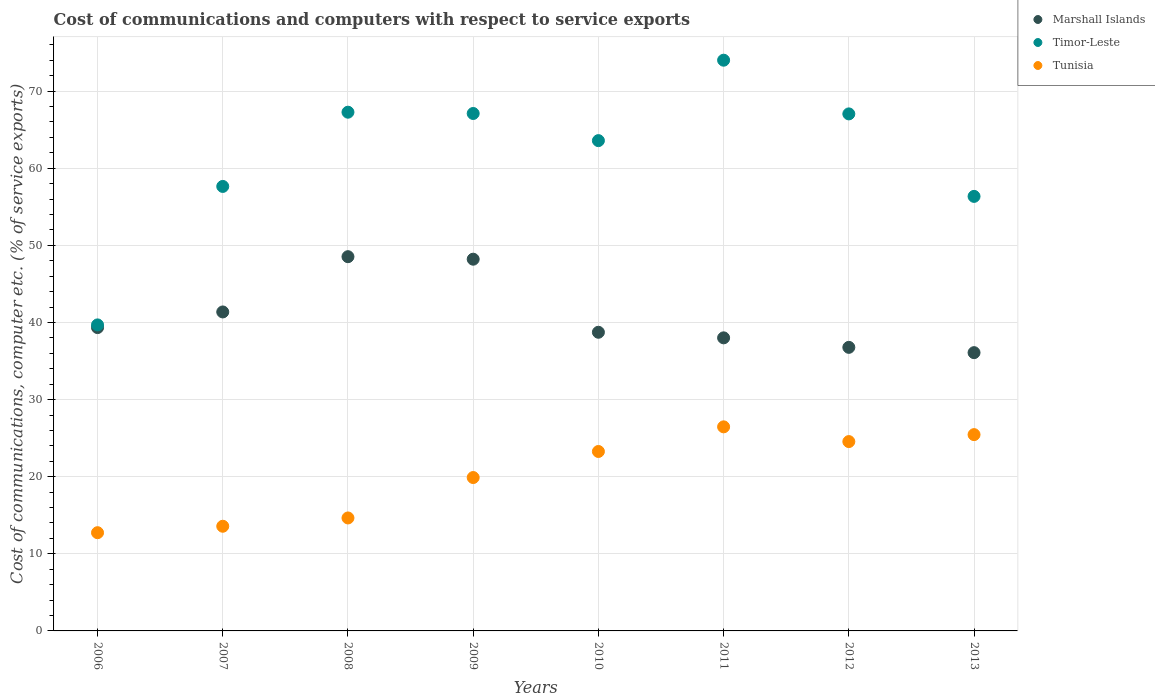Is the number of dotlines equal to the number of legend labels?
Make the answer very short. Yes. What is the cost of communications and computers in Timor-Leste in 2012?
Offer a very short reply. 67.05. Across all years, what is the maximum cost of communications and computers in Timor-Leste?
Keep it short and to the point. 74.01. Across all years, what is the minimum cost of communications and computers in Marshall Islands?
Your answer should be compact. 36.09. In which year was the cost of communications and computers in Timor-Leste minimum?
Keep it short and to the point. 2006. What is the total cost of communications and computers in Marshall Islands in the graph?
Your answer should be very brief. 327.03. What is the difference between the cost of communications and computers in Tunisia in 2009 and that in 2010?
Ensure brevity in your answer.  -3.38. What is the difference between the cost of communications and computers in Marshall Islands in 2013 and the cost of communications and computers in Timor-Leste in 2007?
Your response must be concise. -21.56. What is the average cost of communications and computers in Tunisia per year?
Provide a succinct answer. 20.07. In the year 2008, what is the difference between the cost of communications and computers in Tunisia and cost of communications and computers in Marshall Islands?
Your answer should be compact. -33.88. What is the ratio of the cost of communications and computers in Timor-Leste in 2010 to that in 2011?
Offer a terse response. 0.86. Is the difference between the cost of communications and computers in Tunisia in 2009 and 2012 greater than the difference between the cost of communications and computers in Marshall Islands in 2009 and 2012?
Your response must be concise. No. What is the difference between the highest and the second highest cost of communications and computers in Marshall Islands?
Make the answer very short. 0.33. What is the difference between the highest and the lowest cost of communications and computers in Marshall Islands?
Give a very brief answer. 12.45. In how many years, is the cost of communications and computers in Marshall Islands greater than the average cost of communications and computers in Marshall Islands taken over all years?
Give a very brief answer. 3. Is the sum of the cost of communications and computers in Tunisia in 2010 and 2011 greater than the maximum cost of communications and computers in Timor-Leste across all years?
Ensure brevity in your answer.  No. Is it the case that in every year, the sum of the cost of communications and computers in Timor-Leste and cost of communications and computers in Tunisia  is greater than the cost of communications and computers in Marshall Islands?
Give a very brief answer. Yes. How many dotlines are there?
Your response must be concise. 3. How many years are there in the graph?
Your response must be concise. 8. What is the difference between two consecutive major ticks on the Y-axis?
Make the answer very short. 10. Does the graph contain any zero values?
Offer a very short reply. No. Where does the legend appear in the graph?
Your answer should be compact. Top right. How are the legend labels stacked?
Make the answer very short. Vertical. What is the title of the graph?
Give a very brief answer. Cost of communications and computers with respect to service exports. Does "Tuvalu" appear as one of the legend labels in the graph?
Offer a very short reply. No. What is the label or title of the Y-axis?
Make the answer very short. Cost of communications, computer etc. (% of service exports). What is the Cost of communications, computer etc. (% of service exports) of Marshall Islands in 2006?
Give a very brief answer. 39.34. What is the Cost of communications, computer etc. (% of service exports) in Timor-Leste in 2006?
Provide a succinct answer. 39.69. What is the Cost of communications, computer etc. (% of service exports) in Tunisia in 2006?
Offer a terse response. 12.74. What is the Cost of communications, computer etc. (% of service exports) in Marshall Islands in 2007?
Your answer should be very brief. 41.36. What is the Cost of communications, computer etc. (% of service exports) of Timor-Leste in 2007?
Your answer should be compact. 57.64. What is the Cost of communications, computer etc. (% of service exports) of Tunisia in 2007?
Your answer should be compact. 13.57. What is the Cost of communications, computer etc. (% of service exports) in Marshall Islands in 2008?
Provide a succinct answer. 48.53. What is the Cost of communications, computer etc. (% of service exports) in Timor-Leste in 2008?
Ensure brevity in your answer.  67.27. What is the Cost of communications, computer etc. (% of service exports) in Tunisia in 2008?
Your answer should be very brief. 14.65. What is the Cost of communications, computer etc. (% of service exports) of Marshall Islands in 2009?
Offer a very short reply. 48.2. What is the Cost of communications, computer etc. (% of service exports) of Timor-Leste in 2009?
Offer a very short reply. 67.1. What is the Cost of communications, computer etc. (% of service exports) of Tunisia in 2009?
Offer a terse response. 19.89. What is the Cost of communications, computer etc. (% of service exports) of Marshall Islands in 2010?
Provide a short and direct response. 38.73. What is the Cost of communications, computer etc. (% of service exports) in Timor-Leste in 2010?
Provide a succinct answer. 63.58. What is the Cost of communications, computer etc. (% of service exports) in Tunisia in 2010?
Provide a short and direct response. 23.27. What is the Cost of communications, computer etc. (% of service exports) of Marshall Islands in 2011?
Make the answer very short. 38.01. What is the Cost of communications, computer etc. (% of service exports) in Timor-Leste in 2011?
Keep it short and to the point. 74.01. What is the Cost of communications, computer etc. (% of service exports) of Tunisia in 2011?
Provide a succinct answer. 26.46. What is the Cost of communications, computer etc. (% of service exports) in Marshall Islands in 2012?
Offer a terse response. 36.77. What is the Cost of communications, computer etc. (% of service exports) of Timor-Leste in 2012?
Your answer should be very brief. 67.05. What is the Cost of communications, computer etc. (% of service exports) of Tunisia in 2012?
Give a very brief answer. 24.55. What is the Cost of communications, computer etc. (% of service exports) in Marshall Islands in 2013?
Provide a succinct answer. 36.09. What is the Cost of communications, computer etc. (% of service exports) in Timor-Leste in 2013?
Provide a succinct answer. 56.35. What is the Cost of communications, computer etc. (% of service exports) of Tunisia in 2013?
Give a very brief answer. 25.46. Across all years, what is the maximum Cost of communications, computer etc. (% of service exports) in Marshall Islands?
Ensure brevity in your answer.  48.53. Across all years, what is the maximum Cost of communications, computer etc. (% of service exports) of Timor-Leste?
Ensure brevity in your answer.  74.01. Across all years, what is the maximum Cost of communications, computer etc. (% of service exports) in Tunisia?
Your answer should be very brief. 26.46. Across all years, what is the minimum Cost of communications, computer etc. (% of service exports) in Marshall Islands?
Your answer should be very brief. 36.09. Across all years, what is the minimum Cost of communications, computer etc. (% of service exports) in Timor-Leste?
Provide a succinct answer. 39.69. Across all years, what is the minimum Cost of communications, computer etc. (% of service exports) of Tunisia?
Offer a terse response. 12.74. What is the total Cost of communications, computer etc. (% of service exports) of Marshall Islands in the graph?
Provide a succinct answer. 327.03. What is the total Cost of communications, computer etc. (% of service exports) in Timor-Leste in the graph?
Offer a terse response. 492.68. What is the total Cost of communications, computer etc. (% of service exports) in Tunisia in the graph?
Provide a succinct answer. 160.59. What is the difference between the Cost of communications, computer etc. (% of service exports) of Marshall Islands in 2006 and that in 2007?
Provide a succinct answer. -2.03. What is the difference between the Cost of communications, computer etc. (% of service exports) in Timor-Leste in 2006 and that in 2007?
Give a very brief answer. -17.96. What is the difference between the Cost of communications, computer etc. (% of service exports) in Tunisia in 2006 and that in 2007?
Keep it short and to the point. -0.84. What is the difference between the Cost of communications, computer etc. (% of service exports) of Marshall Islands in 2006 and that in 2008?
Provide a short and direct response. -9.19. What is the difference between the Cost of communications, computer etc. (% of service exports) of Timor-Leste in 2006 and that in 2008?
Your answer should be compact. -27.58. What is the difference between the Cost of communications, computer etc. (% of service exports) of Tunisia in 2006 and that in 2008?
Provide a succinct answer. -1.91. What is the difference between the Cost of communications, computer etc. (% of service exports) in Marshall Islands in 2006 and that in 2009?
Ensure brevity in your answer.  -8.87. What is the difference between the Cost of communications, computer etc. (% of service exports) of Timor-Leste in 2006 and that in 2009?
Offer a very short reply. -27.41. What is the difference between the Cost of communications, computer etc. (% of service exports) of Tunisia in 2006 and that in 2009?
Ensure brevity in your answer.  -7.15. What is the difference between the Cost of communications, computer etc. (% of service exports) of Marshall Islands in 2006 and that in 2010?
Keep it short and to the point. 0.61. What is the difference between the Cost of communications, computer etc. (% of service exports) in Timor-Leste in 2006 and that in 2010?
Provide a succinct answer. -23.89. What is the difference between the Cost of communications, computer etc. (% of service exports) in Tunisia in 2006 and that in 2010?
Offer a very short reply. -10.53. What is the difference between the Cost of communications, computer etc. (% of service exports) in Marshall Islands in 2006 and that in 2011?
Offer a very short reply. 1.33. What is the difference between the Cost of communications, computer etc. (% of service exports) of Timor-Leste in 2006 and that in 2011?
Ensure brevity in your answer.  -34.33. What is the difference between the Cost of communications, computer etc. (% of service exports) of Tunisia in 2006 and that in 2011?
Provide a short and direct response. -13.73. What is the difference between the Cost of communications, computer etc. (% of service exports) in Marshall Islands in 2006 and that in 2012?
Make the answer very short. 2.56. What is the difference between the Cost of communications, computer etc. (% of service exports) of Timor-Leste in 2006 and that in 2012?
Provide a succinct answer. -27.36. What is the difference between the Cost of communications, computer etc. (% of service exports) of Tunisia in 2006 and that in 2012?
Make the answer very short. -11.82. What is the difference between the Cost of communications, computer etc. (% of service exports) in Marshall Islands in 2006 and that in 2013?
Give a very brief answer. 3.25. What is the difference between the Cost of communications, computer etc. (% of service exports) in Timor-Leste in 2006 and that in 2013?
Ensure brevity in your answer.  -16.66. What is the difference between the Cost of communications, computer etc. (% of service exports) in Tunisia in 2006 and that in 2013?
Provide a succinct answer. -12.72. What is the difference between the Cost of communications, computer etc. (% of service exports) in Marshall Islands in 2007 and that in 2008?
Provide a succinct answer. -7.17. What is the difference between the Cost of communications, computer etc. (% of service exports) in Timor-Leste in 2007 and that in 2008?
Provide a succinct answer. -9.63. What is the difference between the Cost of communications, computer etc. (% of service exports) in Tunisia in 2007 and that in 2008?
Offer a very short reply. -1.08. What is the difference between the Cost of communications, computer etc. (% of service exports) in Marshall Islands in 2007 and that in 2009?
Your answer should be very brief. -6.84. What is the difference between the Cost of communications, computer etc. (% of service exports) in Timor-Leste in 2007 and that in 2009?
Provide a succinct answer. -9.46. What is the difference between the Cost of communications, computer etc. (% of service exports) in Tunisia in 2007 and that in 2009?
Keep it short and to the point. -6.32. What is the difference between the Cost of communications, computer etc. (% of service exports) in Marshall Islands in 2007 and that in 2010?
Keep it short and to the point. 2.63. What is the difference between the Cost of communications, computer etc. (% of service exports) of Timor-Leste in 2007 and that in 2010?
Ensure brevity in your answer.  -5.94. What is the difference between the Cost of communications, computer etc. (% of service exports) of Tunisia in 2007 and that in 2010?
Your answer should be very brief. -9.7. What is the difference between the Cost of communications, computer etc. (% of service exports) of Marshall Islands in 2007 and that in 2011?
Offer a terse response. 3.36. What is the difference between the Cost of communications, computer etc. (% of service exports) of Timor-Leste in 2007 and that in 2011?
Ensure brevity in your answer.  -16.37. What is the difference between the Cost of communications, computer etc. (% of service exports) in Tunisia in 2007 and that in 2011?
Your response must be concise. -12.89. What is the difference between the Cost of communications, computer etc. (% of service exports) of Marshall Islands in 2007 and that in 2012?
Provide a succinct answer. 4.59. What is the difference between the Cost of communications, computer etc. (% of service exports) in Timor-Leste in 2007 and that in 2012?
Give a very brief answer. -9.41. What is the difference between the Cost of communications, computer etc. (% of service exports) in Tunisia in 2007 and that in 2012?
Give a very brief answer. -10.98. What is the difference between the Cost of communications, computer etc. (% of service exports) of Marshall Islands in 2007 and that in 2013?
Your response must be concise. 5.28. What is the difference between the Cost of communications, computer etc. (% of service exports) in Timor-Leste in 2007 and that in 2013?
Your response must be concise. 1.29. What is the difference between the Cost of communications, computer etc. (% of service exports) of Tunisia in 2007 and that in 2013?
Your answer should be compact. -11.88. What is the difference between the Cost of communications, computer etc. (% of service exports) in Marshall Islands in 2008 and that in 2009?
Provide a succinct answer. 0.33. What is the difference between the Cost of communications, computer etc. (% of service exports) in Timor-Leste in 2008 and that in 2009?
Keep it short and to the point. 0.17. What is the difference between the Cost of communications, computer etc. (% of service exports) in Tunisia in 2008 and that in 2009?
Offer a terse response. -5.24. What is the difference between the Cost of communications, computer etc. (% of service exports) of Marshall Islands in 2008 and that in 2010?
Your response must be concise. 9.8. What is the difference between the Cost of communications, computer etc. (% of service exports) in Timor-Leste in 2008 and that in 2010?
Offer a very short reply. 3.69. What is the difference between the Cost of communications, computer etc. (% of service exports) in Tunisia in 2008 and that in 2010?
Your answer should be very brief. -8.62. What is the difference between the Cost of communications, computer etc. (% of service exports) of Marshall Islands in 2008 and that in 2011?
Offer a terse response. 10.52. What is the difference between the Cost of communications, computer etc. (% of service exports) of Timor-Leste in 2008 and that in 2011?
Offer a very short reply. -6.74. What is the difference between the Cost of communications, computer etc. (% of service exports) of Tunisia in 2008 and that in 2011?
Your answer should be compact. -11.81. What is the difference between the Cost of communications, computer etc. (% of service exports) in Marshall Islands in 2008 and that in 2012?
Provide a short and direct response. 11.76. What is the difference between the Cost of communications, computer etc. (% of service exports) of Timor-Leste in 2008 and that in 2012?
Offer a terse response. 0.22. What is the difference between the Cost of communications, computer etc. (% of service exports) of Tunisia in 2008 and that in 2012?
Your response must be concise. -9.9. What is the difference between the Cost of communications, computer etc. (% of service exports) in Marshall Islands in 2008 and that in 2013?
Your answer should be compact. 12.45. What is the difference between the Cost of communications, computer etc. (% of service exports) of Timor-Leste in 2008 and that in 2013?
Give a very brief answer. 10.92. What is the difference between the Cost of communications, computer etc. (% of service exports) of Tunisia in 2008 and that in 2013?
Give a very brief answer. -10.81. What is the difference between the Cost of communications, computer etc. (% of service exports) of Marshall Islands in 2009 and that in 2010?
Ensure brevity in your answer.  9.48. What is the difference between the Cost of communications, computer etc. (% of service exports) in Timor-Leste in 2009 and that in 2010?
Keep it short and to the point. 3.52. What is the difference between the Cost of communications, computer etc. (% of service exports) in Tunisia in 2009 and that in 2010?
Ensure brevity in your answer.  -3.38. What is the difference between the Cost of communications, computer etc. (% of service exports) of Marshall Islands in 2009 and that in 2011?
Keep it short and to the point. 10.2. What is the difference between the Cost of communications, computer etc. (% of service exports) in Timor-Leste in 2009 and that in 2011?
Keep it short and to the point. -6.91. What is the difference between the Cost of communications, computer etc. (% of service exports) of Tunisia in 2009 and that in 2011?
Offer a terse response. -6.57. What is the difference between the Cost of communications, computer etc. (% of service exports) of Marshall Islands in 2009 and that in 2012?
Your answer should be compact. 11.43. What is the difference between the Cost of communications, computer etc. (% of service exports) of Timor-Leste in 2009 and that in 2012?
Offer a very short reply. 0.05. What is the difference between the Cost of communications, computer etc. (% of service exports) of Tunisia in 2009 and that in 2012?
Your answer should be compact. -4.66. What is the difference between the Cost of communications, computer etc. (% of service exports) in Marshall Islands in 2009 and that in 2013?
Provide a short and direct response. 12.12. What is the difference between the Cost of communications, computer etc. (% of service exports) in Timor-Leste in 2009 and that in 2013?
Your answer should be compact. 10.75. What is the difference between the Cost of communications, computer etc. (% of service exports) in Tunisia in 2009 and that in 2013?
Offer a terse response. -5.57. What is the difference between the Cost of communications, computer etc. (% of service exports) of Marshall Islands in 2010 and that in 2011?
Give a very brief answer. 0.72. What is the difference between the Cost of communications, computer etc. (% of service exports) of Timor-Leste in 2010 and that in 2011?
Provide a short and direct response. -10.43. What is the difference between the Cost of communications, computer etc. (% of service exports) in Tunisia in 2010 and that in 2011?
Provide a succinct answer. -3.2. What is the difference between the Cost of communications, computer etc. (% of service exports) of Marshall Islands in 2010 and that in 2012?
Provide a short and direct response. 1.96. What is the difference between the Cost of communications, computer etc. (% of service exports) of Timor-Leste in 2010 and that in 2012?
Give a very brief answer. -3.47. What is the difference between the Cost of communications, computer etc. (% of service exports) of Tunisia in 2010 and that in 2012?
Offer a terse response. -1.28. What is the difference between the Cost of communications, computer etc. (% of service exports) in Marshall Islands in 2010 and that in 2013?
Give a very brief answer. 2.64. What is the difference between the Cost of communications, computer etc. (% of service exports) in Timor-Leste in 2010 and that in 2013?
Your answer should be compact. 7.23. What is the difference between the Cost of communications, computer etc. (% of service exports) of Tunisia in 2010 and that in 2013?
Make the answer very short. -2.19. What is the difference between the Cost of communications, computer etc. (% of service exports) in Marshall Islands in 2011 and that in 2012?
Provide a short and direct response. 1.23. What is the difference between the Cost of communications, computer etc. (% of service exports) in Timor-Leste in 2011 and that in 2012?
Keep it short and to the point. 6.96. What is the difference between the Cost of communications, computer etc. (% of service exports) of Tunisia in 2011 and that in 2012?
Your response must be concise. 1.91. What is the difference between the Cost of communications, computer etc. (% of service exports) in Marshall Islands in 2011 and that in 2013?
Keep it short and to the point. 1.92. What is the difference between the Cost of communications, computer etc. (% of service exports) of Timor-Leste in 2011 and that in 2013?
Provide a short and direct response. 17.66. What is the difference between the Cost of communications, computer etc. (% of service exports) of Tunisia in 2011 and that in 2013?
Provide a succinct answer. 1.01. What is the difference between the Cost of communications, computer etc. (% of service exports) in Marshall Islands in 2012 and that in 2013?
Make the answer very short. 0.69. What is the difference between the Cost of communications, computer etc. (% of service exports) in Timor-Leste in 2012 and that in 2013?
Offer a very short reply. 10.7. What is the difference between the Cost of communications, computer etc. (% of service exports) of Tunisia in 2012 and that in 2013?
Your response must be concise. -0.9. What is the difference between the Cost of communications, computer etc. (% of service exports) in Marshall Islands in 2006 and the Cost of communications, computer etc. (% of service exports) in Timor-Leste in 2007?
Offer a terse response. -18.31. What is the difference between the Cost of communications, computer etc. (% of service exports) in Marshall Islands in 2006 and the Cost of communications, computer etc. (% of service exports) in Tunisia in 2007?
Offer a very short reply. 25.76. What is the difference between the Cost of communications, computer etc. (% of service exports) in Timor-Leste in 2006 and the Cost of communications, computer etc. (% of service exports) in Tunisia in 2007?
Offer a very short reply. 26.11. What is the difference between the Cost of communications, computer etc. (% of service exports) of Marshall Islands in 2006 and the Cost of communications, computer etc. (% of service exports) of Timor-Leste in 2008?
Give a very brief answer. -27.93. What is the difference between the Cost of communications, computer etc. (% of service exports) in Marshall Islands in 2006 and the Cost of communications, computer etc. (% of service exports) in Tunisia in 2008?
Ensure brevity in your answer.  24.69. What is the difference between the Cost of communications, computer etc. (% of service exports) in Timor-Leste in 2006 and the Cost of communications, computer etc. (% of service exports) in Tunisia in 2008?
Your answer should be compact. 25.04. What is the difference between the Cost of communications, computer etc. (% of service exports) in Marshall Islands in 2006 and the Cost of communications, computer etc. (% of service exports) in Timor-Leste in 2009?
Offer a very short reply. -27.76. What is the difference between the Cost of communications, computer etc. (% of service exports) of Marshall Islands in 2006 and the Cost of communications, computer etc. (% of service exports) of Tunisia in 2009?
Offer a very short reply. 19.45. What is the difference between the Cost of communications, computer etc. (% of service exports) in Timor-Leste in 2006 and the Cost of communications, computer etc. (% of service exports) in Tunisia in 2009?
Your answer should be compact. 19.8. What is the difference between the Cost of communications, computer etc. (% of service exports) of Marshall Islands in 2006 and the Cost of communications, computer etc. (% of service exports) of Timor-Leste in 2010?
Provide a short and direct response. -24.24. What is the difference between the Cost of communications, computer etc. (% of service exports) in Marshall Islands in 2006 and the Cost of communications, computer etc. (% of service exports) in Tunisia in 2010?
Ensure brevity in your answer.  16.07. What is the difference between the Cost of communications, computer etc. (% of service exports) in Timor-Leste in 2006 and the Cost of communications, computer etc. (% of service exports) in Tunisia in 2010?
Give a very brief answer. 16.42. What is the difference between the Cost of communications, computer etc. (% of service exports) in Marshall Islands in 2006 and the Cost of communications, computer etc. (% of service exports) in Timor-Leste in 2011?
Provide a succinct answer. -34.67. What is the difference between the Cost of communications, computer etc. (% of service exports) in Marshall Islands in 2006 and the Cost of communications, computer etc. (% of service exports) in Tunisia in 2011?
Offer a terse response. 12.87. What is the difference between the Cost of communications, computer etc. (% of service exports) in Timor-Leste in 2006 and the Cost of communications, computer etc. (% of service exports) in Tunisia in 2011?
Keep it short and to the point. 13.22. What is the difference between the Cost of communications, computer etc. (% of service exports) in Marshall Islands in 2006 and the Cost of communications, computer etc. (% of service exports) in Timor-Leste in 2012?
Provide a short and direct response. -27.71. What is the difference between the Cost of communications, computer etc. (% of service exports) of Marshall Islands in 2006 and the Cost of communications, computer etc. (% of service exports) of Tunisia in 2012?
Make the answer very short. 14.78. What is the difference between the Cost of communications, computer etc. (% of service exports) in Timor-Leste in 2006 and the Cost of communications, computer etc. (% of service exports) in Tunisia in 2012?
Your answer should be compact. 15.13. What is the difference between the Cost of communications, computer etc. (% of service exports) of Marshall Islands in 2006 and the Cost of communications, computer etc. (% of service exports) of Timor-Leste in 2013?
Make the answer very short. -17.01. What is the difference between the Cost of communications, computer etc. (% of service exports) in Marshall Islands in 2006 and the Cost of communications, computer etc. (% of service exports) in Tunisia in 2013?
Make the answer very short. 13.88. What is the difference between the Cost of communications, computer etc. (% of service exports) in Timor-Leste in 2006 and the Cost of communications, computer etc. (% of service exports) in Tunisia in 2013?
Keep it short and to the point. 14.23. What is the difference between the Cost of communications, computer etc. (% of service exports) of Marshall Islands in 2007 and the Cost of communications, computer etc. (% of service exports) of Timor-Leste in 2008?
Ensure brevity in your answer.  -25.9. What is the difference between the Cost of communications, computer etc. (% of service exports) of Marshall Islands in 2007 and the Cost of communications, computer etc. (% of service exports) of Tunisia in 2008?
Ensure brevity in your answer.  26.71. What is the difference between the Cost of communications, computer etc. (% of service exports) of Timor-Leste in 2007 and the Cost of communications, computer etc. (% of service exports) of Tunisia in 2008?
Your answer should be very brief. 42.99. What is the difference between the Cost of communications, computer etc. (% of service exports) of Marshall Islands in 2007 and the Cost of communications, computer etc. (% of service exports) of Timor-Leste in 2009?
Offer a very short reply. -25.74. What is the difference between the Cost of communications, computer etc. (% of service exports) of Marshall Islands in 2007 and the Cost of communications, computer etc. (% of service exports) of Tunisia in 2009?
Ensure brevity in your answer.  21.47. What is the difference between the Cost of communications, computer etc. (% of service exports) of Timor-Leste in 2007 and the Cost of communications, computer etc. (% of service exports) of Tunisia in 2009?
Provide a succinct answer. 37.75. What is the difference between the Cost of communications, computer etc. (% of service exports) in Marshall Islands in 2007 and the Cost of communications, computer etc. (% of service exports) in Timor-Leste in 2010?
Your response must be concise. -22.22. What is the difference between the Cost of communications, computer etc. (% of service exports) in Marshall Islands in 2007 and the Cost of communications, computer etc. (% of service exports) in Tunisia in 2010?
Offer a terse response. 18.09. What is the difference between the Cost of communications, computer etc. (% of service exports) of Timor-Leste in 2007 and the Cost of communications, computer etc. (% of service exports) of Tunisia in 2010?
Give a very brief answer. 34.37. What is the difference between the Cost of communications, computer etc. (% of service exports) in Marshall Islands in 2007 and the Cost of communications, computer etc. (% of service exports) in Timor-Leste in 2011?
Your response must be concise. -32.65. What is the difference between the Cost of communications, computer etc. (% of service exports) in Marshall Islands in 2007 and the Cost of communications, computer etc. (% of service exports) in Tunisia in 2011?
Keep it short and to the point. 14.9. What is the difference between the Cost of communications, computer etc. (% of service exports) of Timor-Leste in 2007 and the Cost of communications, computer etc. (% of service exports) of Tunisia in 2011?
Offer a terse response. 31.18. What is the difference between the Cost of communications, computer etc. (% of service exports) in Marshall Islands in 2007 and the Cost of communications, computer etc. (% of service exports) in Timor-Leste in 2012?
Your answer should be very brief. -25.68. What is the difference between the Cost of communications, computer etc. (% of service exports) in Marshall Islands in 2007 and the Cost of communications, computer etc. (% of service exports) in Tunisia in 2012?
Ensure brevity in your answer.  16.81. What is the difference between the Cost of communications, computer etc. (% of service exports) of Timor-Leste in 2007 and the Cost of communications, computer etc. (% of service exports) of Tunisia in 2012?
Your answer should be very brief. 33.09. What is the difference between the Cost of communications, computer etc. (% of service exports) in Marshall Islands in 2007 and the Cost of communications, computer etc. (% of service exports) in Timor-Leste in 2013?
Give a very brief answer. -14.99. What is the difference between the Cost of communications, computer etc. (% of service exports) in Marshall Islands in 2007 and the Cost of communications, computer etc. (% of service exports) in Tunisia in 2013?
Offer a terse response. 15.91. What is the difference between the Cost of communications, computer etc. (% of service exports) of Timor-Leste in 2007 and the Cost of communications, computer etc. (% of service exports) of Tunisia in 2013?
Offer a very short reply. 32.19. What is the difference between the Cost of communications, computer etc. (% of service exports) in Marshall Islands in 2008 and the Cost of communications, computer etc. (% of service exports) in Timor-Leste in 2009?
Your response must be concise. -18.57. What is the difference between the Cost of communications, computer etc. (% of service exports) in Marshall Islands in 2008 and the Cost of communications, computer etc. (% of service exports) in Tunisia in 2009?
Your answer should be compact. 28.64. What is the difference between the Cost of communications, computer etc. (% of service exports) in Timor-Leste in 2008 and the Cost of communications, computer etc. (% of service exports) in Tunisia in 2009?
Your answer should be compact. 47.38. What is the difference between the Cost of communications, computer etc. (% of service exports) in Marshall Islands in 2008 and the Cost of communications, computer etc. (% of service exports) in Timor-Leste in 2010?
Provide a short and direct response. -15.05. What is the difference between the Cost of communications, computer etc. (% of service exports) of Marshall Islands in 2008 and the Cost of communications, computer etc. (% of service exports) of Tunisia in 2010?
Make the answer very short. 25.26. What is the difference between the Cost of communications, computer etc. (% of service exports) of Timor-Leste in 2008 and the Cost of communications, computer etc. (% of service exports) of Tunisia in 2010?
Your answer should be very brief. 44. What is the difference between the Cost of communications, computer etc. (% of service exports) of Marshall Islands in 2008 and the Cost of communications, computer etc. (% of service exports) of Timor-Leste in 2011?
Offer a very short reply. -25.48. What is the difference between the Cost of communications, computer etc. (% of service exports) in Marshall Islands in 2008 and the Cost of communications, computer etc. (% of service exports) in Tunisia in 2011?
Your answer should be compact. 22.07. What is the difference between the Cost of communications, computer etc. (% of service exports) in Timor-Leste in 2008 and the Cost of communications, computer etc. (% of service exports) in Tunisia in 2011?
Keep it short and to the point. 40.8. What is the difference between the Cost of communications, computer etc. (% of service exports) in Marshall Islands in 2008 and the Cost of communications, computer etc. (% of service exports) in Timor-Leste in 2012?
Make the answer very short. -18.52. What is the difference between the Cost of communications, computer etc. (% of service exports) in Marshall Islands in 2008 and the Cost of communications, computer etc. (% of service exports) in Tunisia in 2012?
Make the answer very short. 23.98. What is the difference between the Cost of communications, computer etc. (% of service exports) of Timor-Leste in 2008 and the Cost of communications, computer etc. (% of service exports) of Tunisia in 2012?
Provide a short and direct response. 42.71. What is the difference between the Cost of communications, computer etc. (% of service exports) in Marshall Islands in 2008 and the Cost of communications, computer etc. (% of service exports) in Timor-Leste in 2013?
Provide a succinct answer. -7.82. What is the difference between the Cost of communications, computer etc. (% of service exports) in Marshall Islands in 2008 and the Cost of communications, computer etc. (% of service exports) in Tunisia in 2013?
Your response must be concise. 23.07. What is the difference between the Cost of communications, computer etc. (% of service exports) of Timor-Leste in 2008 and the Cost of communications, computer etc. (% of service exports) of Tunisia in 2013?
Give a very brief answer. 41.81. What is the difference between the Cost of communications, computer etc. (% of service exports) of Marshall Islands in 2009 and the Cost of communications, computer etc. (% of service exports) of Timor-Leste in 2010?
Ensure brevity in your answer.  -15.38. What is the difference between the Cost of communications, computer etc. (% of service exports) of Marshall Islands in 2009 and the Cost of communications, computer etc. (% of service exports) of Tunisia in 2010?
Offer a terse response. 24.94. What is the difference between the Cost of communications, computer etc. (% of service exports) of Timor-Leste in 2009 and the Cost of communications, computer etc. (% of service exports) of Tunisia in 2010?
Offer a very short reply. 43.83. What is the difference between the Cost of communications, computer etc. (% of service exports) in Marshall Islands in 2009 and the Cost of communications, computer etc. (% of service exports) in Timor-Leste in 2011?
Offer a terse response. -25.81. What is the difference between the Cost of communications, computer etc. (% of service exports) in Marshall Islands in 2009 and the Cost of communications, computer etc. (% of service exports) in Tunisia in 2011?
Provide a succinct answer. 21.74. What is the difference between the Cost of communications, computer etc. (% of service exports) of Timor-Leste in 2009 and the Cost of communications, computer etc. (% of service exports) of Tunisia in 2011?
Your answer should be compact. 40.64. What is the difference between the Cost of communications, computer etc. (% of service exports) of Marshall Islands in 2009 and the Cost of communications, computer etc. (% of service exports) of Timor-Leste in 2012?
Your answer should be compact. -18.84. What is the difference between the Cost of communications, computer etc. (% of service exports) in Marshall Islands in 2009 and the Cost of communications, computer etc. (% of service exports) in Tunisia in 2012?
Keep it short and to the point. 23.65. What is the difference between the Cost of communications, computer etc. (% of service exports) in Timor-Leste in 2009 and the Cost of communications, computer etc. (% of service exports) in Tunisia in 2012?
Provide a short and direct response. 42.55. What is the difference between the Cost of communications, computer etc. (% of service exports) in Marshall Islands in 2009 and the Cost of communications, computer etc. (% of service exports) in Timor-Leste in 2013?
Your answer should be compact. -8.15. What is the difference between the Cost of communications, computer etc. (% of service exports) of Marshall Islands in 2009 and the Cost of communications, computer etc. (% of service exports) of Tunisia in 2013?
Your response must be concise. 22.75. What is the difference between the Cost of communications, computer etc. (% of service exports) in Timor-Leste in 2009 and the Cost of communications, computer etc. (% of service exports) in Tunisia in 2013?
Offer a very short reply. 41.64. What is the difference between the Cost of communications, computer etc. (% of service exports) of Marshall Islands in 2010 and the Cost of communications, computer etc. (% of service exports) of Timor-Leste in 2011?
Your response must be concise. -35.28. What is the difference between the Cost of communications, computer etc. (% of service exports) of Marshall Islands in 2010 and the Cost of communications, computer etc. (% of service exports) of Tunisia in 2011?
Keep it short and to the point. 12.26. What is the difference between the Cost of communications, computer etc. (% of service exports) in Timor-Leste in 2010 and the Cost of communications, computer etc. (% of service exports) in Tunisia in 2011?
Ensure brevity in your answer.  37.12. What is the difference between the Cost of communications, computer etc. (% of service exports) in Marshall Islands in 2010 and the Cost of communications, computer etc. (% of service exports) in Timor-Leste in 2012?
Make the answer very short. -28.32. What is the difference between the Cost of communications, computer etc. (% of service exports) of Marshall Islands in 2010 and the Cost of communications, computer etc. (% of service exports) of Tunisia in 2012?
Offer a very short reply. 14.18. What is the difference between the Cost of communications, computer etc. (% of service exports) in Timor-Leste in 2010 and the Cost of communications, computer etc. (% of service exports) in Tunisia in 2012?
Your answer should be compact. 39.03. What is the difference between the Cost of communications, computer etc. (% of service exports) in Marshall Islands in 2010 and the Cost of communications, computer etc. (% of service exports) in Timor-Leste in 2013?
Make the answer very short. -17.62. What is the difference between the Cost of communications, computer etc. (% of service exports) in Marshall Islands in 2010 and the Cost of communications, computer etc. (% of service exports) in Tunisia in 2013?
Provide a short and direct response. 13.27. What is the difference between the Cost of communications, computer etc. (% of service exports) of Timor-Leste in 2010 and the Cost of communications, computer etc. (% of service exports) of Tunisia in 2013?
Offer a terse response. 38.12. What is the difference between the Cost of communications, computer etc. (% of service exports) in Marshall Islands in 2011 and the Cost of communications, computer etc. (% of service exports) in Timor-Leste in 2012?
Your response must be concise. -29.04. What is the difference between the Cost of communications, computer etc. (% of service exports) of Marshall Islands in 2011 and the Cost of communications, computer etc. (% of service exports) of Tunisia in 2012?
Your answer should be compact. 13.45. What is the difference between the Cost of communications, computer etc. (% of service exports) of Timor-Leste in 2011 and the Cost of communications, computer etc. (% of service exports) of Tunisia in 2012?
Ensure brevity in your answer.  49.46. What is the difference between the Cost of communications, computer etc. (% of service exports) in Marshall Islands in 2011 and the Cost of communications, computer etc. (% of service exports) in Timor-Leste in 2013?
Your answer should be compact. -18.34. What is the difference between the Cost of communications, computer etc. (% of service exports) of Marshall Islands in 2011 and the Cost of communications, computer etc. (% of service exports) of Tunisia in 2013?
Offer a terse response. 12.55. What is the difference between the Cost of communications, computer etc. (% of service exports) of Timor-Leste in 2011 and the Cost of communications, computer etc. (% of service exports) of Tunisia in 2013?
Ensure brevity in your answer.  48.55. What is the difference between the Cost of communications, computer etc. (% of service exports) in Marshall Islands in 2012 and the Cost of communications, computer etc. (% of service exports) in Timor-Leste in 2013?
Your answer should be compact. -19.58. What is the difference between the Cost of communications, computer etc. (% of service exports) in Marshall Islands in 2012 and the Cost of communications, computer etc. (% of service exports) in Tunisia in 2013?
Make the answer very short. 11.32. What is the difference between the Cost of communications, computer etc. (% of service exports) in Timor-Leste in 2012 and the Cost of communications, computer etc. (% of service exports) in Tunisia in 2013?
Your answer should be compact. 41.59. What is the average Cost of communications, computer etc. (% of service exports) in Marshall Islands per year?
Provide a short and direct response. 40.88. What is the average Cost of communications, computer etc. (% of service exports) of Timor-Leste per year?
Keep it short and to the point. 61.59. What is the average Cost of communications, computer etc. (% of service exports) of Tunisia per year?
Your response must be concise. 20.07. In the year 2006, what is the difference between the Cost of communications, computer etc. (% of service exports) in Marshall Islands and Cost of communications, computer etc. (% of service exports) in Timor-Leste?
Make the answer very short. -0.35. In the year 2006, what is the difference between the Cost of communications, computer etc. (% of service exports) of Marshall Islands and Cost of communications, computer etc. (% of service exports) of Tunisia?
Keep it short and to the point. 26.6. In the year 2006, what is the difference between the Cost of communications, computer etc. (% of service exports) in Timor-Leste and Cost of communications, computer etc. (% of service exports) in Tunisia?
Your answer should be compact. 26.95. In the year 2007, what is the difference between the Cost of communications, computer etc. (% of service exports) of Marshall Islands and Cost of communications, computer etc. (% of service exports) of Timor-Leste?
Provide a succinct answer. -16.28. In the year 2007, what is the difference between the Cost of communications, computer etc. (% of service exports) of Marshall Islands and Cost of communications, computer etc. (% of service exports) of Tunisia?
Provide a short and direct response. 27.79. In the year 2007, what is the difference between the Cost of communications, computer etc. (% of service exports) in Timor-Leste and Cost of communications, computer etc. (% of service exports) in Tunisia?
Your response must be concise. 44.07. In the year 2008, what is the difference between the Cost of communications, computer etc. (% of service exports) in Marshall Islands and Cost of communications, computer etc. (% of service exports) in Timor-Leste?
Your answer should be very brief. -18.74. In the year 2008, what is the difference between the Cost of communications, computer etc. (% of service exports) in Marshall Islands and Cost of communications, computer etc. (% of service exports) in Tunisia?
Ensure brevity in your answer.  33.88. In the year 2008, what is the difference between the Cost of communications, computer etc. (% of service exports) in Timor-Leste and Cost of communications, computer etc. (% of service exports) in Tunisia?
Your answer should be very brief. 52.62. In the year 2009, what is the difference between the Cost of communications, computer etc. (% of service exports) of Marshall Islands and Cost of communications, computer etc. (% of service exports) of Timor-Leste?
Keep it short and to the point. -18.9. In the year 2009, what is the difference between the Cost of communications, computer etc. (% of service exports) of Marshall Islands and Cost of communications, computer etc. (% of service exports) of Tunisia?
Give a very brief answer. 28.31. In the year 2009, what is the difference between the Cost of communications, computer etc. (% of service exports) of Timor-Leste and Cost of communications, computer etc. (% of service exports) of Tunisia?
Provide a short and direct response. 47.21. In the year 2010, what is the difference between the Cost of communications, computer etc. (% of service exports) in Marshall Islands and Cost of communications, computer etc. (% of service exports) in Timor-Leste?
Keep it short and to the point. -24.85. In the year 2010, what is the difference between the Cost of communications, computer etc. (% of service exports) in Marshall Islands and Cost of communications, computer etc. (% of service exports) in Tunisia?
Your answer should be compact. 15.46. In the year 2010, what is the difference between the Cost of communications, computer etc. (% of service exports) in Timor-Leste and Cost of communications, computer etc. (% of service exports) in Tunisia?
Provide a succinct answer. 40.31. In the year 2011, what is the difference between the Cost of communications, computer etc. (% of service exports) of Marshall Islands and Cost of communications, computer etc. (% of service exports) of Timor-Leste?
Ensure brevity in your answer.  -36. In the year 2011, what is the difference between the Cost of communications, computer etc. (% of service exports) in Marshall Islands and Cost of communications, computer etc. (% of service exports) in Tunisia?
Offer a terse response. 11.54. In the year 2011, what is the difference between the Cost of communications, computer etc. (% of service exports) in Timor-Leste and Cost of communications, computer etc. (% of service exports) in Tunisia?
Your response must be concise. 47.55. In the year 2012, what is the difference between the Cost of communications, computer etc. (% of service exports) of Marshall Islands and Cost of communications, computer etc. (% of service exports) of Timor-Leste?
Provide a succinct answer. -30.27. In the year 2012, what is the difference between the Cost of communications, computer etc. (% of service exports) in Marshall Islands and Cost of communications, computer etc. (% of service exports) in Tunisia?
Keep it short and to the point. 12.22. In the year 2012, what is the difference between the Cost of communications, computer etc. (% of service exports) in Timor-Leste and Cost of communications, computer etc. (% of service exports) in Tunisia?
Provide a short and direct response. 42.49. In the year 2013, what is the difference between the Cost of communications, computer etc. (% of service exports) of Marshall Islands and Cost of communications, computer etc. (% of service exports) of Timor-Leste?
Offer a very short reply. -20.26. In the year 2013, what is the difference between the Cost of communications, computer etc. (% of service exports) of Marshall Islands and Cost of communications, computer etc. (% of service exports) of Tunisia?
Provide a succinct answer. 10.63. In the year 2013, what is the difference between the Cost of communications, computer etc. (% of service exports) in Timor-Leste and Cost of communications, computer etc. (% of service exports) in Tunisia?
Make the answer very short. 30.89. What is the ratio of the Cost of communications, computer etc. (% of service exports) in Marshall Islands in 2006 to that in 2007?
Your response must be concise. 0.95. What is the ratio of the Cost of communications, computer etc. (% of service exports) of Timor-Leste in 2006 to that in 2007?
Ensure brevity in your answer.  0.69. What is the ratio of the Cost of communications, computer etc. (% of service exports) in Tunisia in 2006 to that in 2007?
Keep it short and to the point. 0.94. What is the ratio of the Cost of communications, computer etc. (% of service exports) in Marshall Islands in 2006 to that in 2008?
Offer a terse response. 0.81. What is the ratio of the Cost of communications, computer etc. (% of service exports) of Timor-Leste in 2006 to that in 2008?
Your response must be concise. 0.59. What is the ratio of the Cost of communications, computer etc. (% of service exports) of Tunisia in 2006 to that in 2008?
Provide a succinct answer. 0.87. What is the ratio of the Cost of communications, computer etc. (% of service exports) of Marshall Islands in 2006 to that in 2009?
Your answer should be very brief. 0.82. What is the ratio of the Cost of communications, computer etc. (% of service exports) in Timor-Leste in 2006 to that in 2009?
Ensure brevity in your answer.  0.59. What is the ratio of the Cost of communications, computer etc. (% of service exports) in Tunisia in 2006 to that in 2009?
Make the answer very short. 0.64. What is the ratio of the Cost of communications, computer etc. (% of service exports) in Marshall Islands in 2006 to that in 2010?
Your answer should be very brief. 1.02. What is the ratio of the Cost of communications, computer etc. (% of service exports) of Timor-Leste in 2006 to that in 2010?
Make the answer very short. 0.62. What is the ratio of the Cost of communications, computer etc. (% of service exports) in Tunisia in 2006 to that in 2010?
Offer a terse response. 0.55. What is the ratio of the Cost of communications, computer etc. (% of service exports) of Marshall Islands in 2006 to that in 2011?
Keep it short and to the point. 1.03. What is the ratio of the Cost of communications, computer etc. (% of service exports) in Timor-Leste in 2006 to that in 2011?
Give a very brief answer. 0.54. What is the ratio of the Cost of communications, computer etc. (% of service exports) in Tunisia in 2006 to that in 2011?
Provide a short and direct response. 0.48. What is the ratio of the Cost of communications, computer etc. (% of service exports) of Marshall Islands in 2006 to that in 2012?
Your answer should be compact. 1.07. What is the ratio of the Cost of communications, computer etc. (% of service exports) in Timor-Leste in 2006 to that in 2012?
Ensure brevity in your answer.  0.59. What is the ratio of the Cost of communications, computer etc. (% of service exports) in Tunisia in 2006 to that in 2012?
Ensure brevity in your answer.  0.52. What is the ratio of the Cost of communications, computer etc. (% of service exports) in Marshall Islands in 2006 to that in 2013?
Make the answer very short. 1.09. What is the ratio of the Cost of communications, computer etc. (% of service exports) of Timor-Leste in 2006 to that in 2013?
Offer a very short reply. 0.7. What is the ratio of the Cost of communications, computer etc. (% of service exports) in Tunisia in 2006 to that in 2013?
Provide a succinct answer. 0.5. What is the ratio of the Cost of communications, computer etc. (% of service exports) in Marshall Islands in 2007 to that in 2008?
Provide a succinct answer. 0.85. What is the ratio of the Cost of communications, computer etc. (% of service exports) of Timor-Leste in 2007 to that in 2008?
Provide a short and direct response. 0.86. What is the ratio of the Cost of communications, computer etc. (% of service exports) of Tunisia in 2007 to that in 2008?
Your answer should be compact. 0.93. What is the ratio of the Cost of communications, computer etc. (% of service exports) of Marshall Islands in 2007 to that in 2009?
Your answer should be very brief. 0.86. What is the ratio of the Cost of communications, computer etc. (% of service exports) in Timor-Leste in 2007 to that in 2009?
Give a very brief answer. 0.86. What is the ratio of the Cost of communications, computer etc. (% of service exports) in Tunisia in 2007 to that in 2009?
Ensure brevity in your answer.  0.68. What is the ratio of the Cost of communications, computer etc. (% of service exports) in Marshall Islands in 2007 to that in 2010?
Make the answer very short. 1.07. What is the ratio of the Cost of communications, computer etc. (% of service exports) in Timor-Leste in 2007 to that in 2010?
Make the answer very short. 0.91. What is the ratio of the Cost of communications, computer etc. (% of service exports) of Tunisia in 2007 to that in 2010?
Ensure brevity in your answer.  0.58. What is the ratio of the Cost of communications, computer etc. (% of service exports) of Marshall Islands in 2007 to that in 2011?
Give a very brief answer. 1.09. What is the ratio of the Cost of communications, computer etc. (% of service exports) of Timor-Leste in 2007 to that in 2011?
Keep it short and to the point. 0.78. What is the ratio of the Cost of communications, computer etc. (% of service exports) of Tunisia in 2007 to that in 2011?
Provide a short and direct response. 0.51. What is the ratio of the Cost of communications, computer etc. (% of service exports) of Marshall Islands in 2007 to that in 2012?
Offer a terse response. 1.12. What is the ratio of the Cost of communications, computer etc. (% of service exports) in Timor-Leste in 2007 to that in 2012?
Ensure brevity in your answer.  0.86. What is the ratio of the Cost of communications, computer etc. (% of service exports) in Tunisia in 2007 to that in 2012?
Your answer should be compact. 0.55. What is the ratio of the Cost of communications, computer etc. (% of service exports) in Marshall Islands in 2007 to that in 2013?
Your answer should be very brief. 1.15. What is the ratio of the Cost of communications, computer etc. (% of service exports) of Timor-Leste in 2007 to that in 2013?
Offer a terse response. 1.02. What is the ratio of the Cost of communications, computer etc. (% of service exports) of Tunisia in 2007 to that in 2013?
Make the answer very short. 0.53. What is the ratio of the Cost of communications, computer etc. (% of service exports) of Marshall Islands in 2008 to that in 2009?
Ensure brevity in your answer.  1.01. What is the ratio of the Cost of communications, computer etc. (% of service exports) in Timor-Leste in 2008 to that in 2009?
Provide a succinct answer. 1. What is the ratio of the Cost of communications, computer etc. (% of service exports) of Tunisia in 2008 to that in 2009?
Your answer should be very brief. 0.74. What is the ratio of the Cost of communications, computer etc. (% of service exports) of Marshall Islands in 2008 to that in 2010?
Ensure brevity in your answer.  1.25. What is the ratio of the Cost of communications, computer etc. (% of service exports) of Timor-Leste in 2008 to that in 2010?
Give a very brief answer. 1.06. What is the ratio of the Cost of communications, computer etc. (% of service exports) in Tunisia in 2008 to that in 2010?
Your answer should be very brief. 0.63. What is the ratio of the Cost of communications, computer etc. (% of service exports) in Marshall Islands in 2008 to that in 2011?
Offer a very short reply. 1.28. What is the ratio of the Cost of communications, computer etc. (% of service exports) in Timor-Leste in 2008 to that in 2011?
Your answer should be compact. 0.91. What is the ratio of the Cost of communications, computer etc. (% of service exports) of Tunisia in 2008 to that in 2011?
Provide a succinct answer. 0.55. What is the ratio of the Cost of communications, computer etc. (% of service exports) of Marshall Islands in 2008 to that in 2012?
Provide a succinct answer. 1.32. What is the ratio of the Cost of communications, computer etc. (% of service exports) of Tunisia in 2008 to that in 2012?
Ensure brevity in your answer.  0.6. What is the ratio of the Cost of communications, computer etc. (% of service exports) in Marshall Islands in 2008 to that in 2013?
Give a very brief answer. 1.34. What is the ratio of the Cost of communications, computer etc. (% of service exports) of Timor-Leste in 2008 to that in 2013?
Keep it short and to the point. 1.19. What is the ratio of the Cost of communications, computer etc. (% of service exports) in Tunisia in 2008 to that in 2013?
Provide a succinct answer. 0.58. What is the ratio of the Cost of communications, computer etc. (% of service exports) in Marshall Islands in 2009 to that in 2010?
Offer a terse response. 1.24. What is the ratio of the Cost of communications, computer etc. (% of service exports) of Timor-Leste in 2009 to that in 2010?
Provide a short and direct response. 1.06. What is the ratio of the Cost of communications, computer etc. (% of service exports) of Tunisia in 2009 to that in 2010?
Provide a short and direct response. 0.85. What is the ratio of the Cost of communications, computer etc. (% of service exports) in Marshall Islands in 2009 to that in 2011?
Offer a terse response. 1.27. What is the ratio of the Cost of communications, computer etc. (% of service exports) of Timor-Leste in 2009 to that in 2011?
Make the answer very short. 0.91. What is the ratio of the Cost of communications, computer etc. (% of service exports) in Tunisia in 2009 to that in 2011?
Provide a short and direct response. 0.75. What is the ratio of the Cost of communications, computer etc. (% of service exports) of Marshall Islands in 2009 to that in 2012?
Your response must be concise. 1.31. What is the ratio of the Cost of communications, computer etc. (% of service exports) of Tunisia in 2009 to that in 2012?
Keep it short and to the point. 0.81. What is the ratio of the Cost of communications, computer etc. (% of service exports) of Marshall Islands in 2009 to that in 2013?
Offer a terse response. 1.34. What is the ratio of the Cost of communications, computer etc. (% of service exports) in Timor-Leste in 2009 to that in 2013?
Offer a very short reply. 1.19. What is the ratio of the Cost of communications, computer etc. (% of service exports) in Tunisia in 2009 to that in 2013?
Your response must be concise. 0.78. What is the ratio of the Cost of communications, computer etc. (% of service exports) of Timor-Leste in 2010 to that in 2011?
Keep it short and to the point. 0.86. What is the ratio of the Cost of communications, computer etc. (% of service exports) of Tunisia in 2010 to that in 2011?
Your answer should be compact. 0.88. What is the ratio of the Cost of communications, computer etc. (% of service exports) in Marshall Islands in 2010 to that in 2012?
Ensure brevity in your answer.  1.05. What is the ratio of the Cost of communications, computer etc. (% of service exports) in Timor-Leste in 2010 to that in 2012?
Your response must be concise. 0.95. What is the ratio of the Cost of communications, computer etc. (% of service exports) of Tunisia in 2010 to that in 2012?
Keep it short and to the point. 0.95. What is the ratio of the Cost of communications, computer etc. (% of service exports) in Marshall Islands in 2010 to that in 2013?
Offer a terse response. 1.07. What is the ratio of the Cost of communications, computer etc. (% of service exports) in Timor-Leste in 2010 to that in 2013?
Provide a succinct answer. 1.13. What is the ratio of the Cost of communications, computer etc. (% of service exports) in Tunisia in 2010 to that in 2013?
Your answer should be very brief. 0.91. What is the ratio of the Cost of communications, computer etc. (% of service exports) of Marshall Islands in 2011 to that in 2012?
Offer a terse response. 1.03. What is the ratio of the Cost of communications, computer etc. (% of service exports) in Timor-Leste in 2011 to that in 2012?
Provide a short and direct response. 1.1. What is the ratio of the Cost of communications, computer etc. (% of service exports) of Tunisia in 2011 to that in 2012?
Ensure brevity in your answer.  1.08. What is the ratio of the Cost of communications, computer etc. (% of service exports) of Marshall Islands in 2011 to that in 2013?
Keep it short and to the point. 1.05. What is the ratio of the Cost of communications, computer etc. (% of service exports) in Timor-Leste in 2011 to that in 2013?
Your answer should be very brief. 1.31. What is the ratio of the Cost of communications, computer etc. (% of service exports) in Tunisia in 2011 to that in 2013?
Provide a succinct answer. 1.04. What is the ratio of the Cost of communications, computer etc. (% of service exports) in Marshall Islands in 2012 to that in 2013?
Your response must be concise. 1.02. What is the ratio of the Cost of communications, computer etc. (% of service exports) of Timor-Leste in 2012 to that in 2013?
Your response must be concise. 1.19. What is the ratio of the Cost of communications, computer etc. (% of service exports) of Tunisia in 2012 to that in 2013?
Your answer should be very brief. 0.96. What is the difference between the highest and the second highest Cost of communications, computer etc. (% of service exports) in Marshall Islands?
Offer a very short reply. 0.33. What is the difference between the highest and the second highest Cost of communications, computer etc. (% of service exports) in Timor-Leste?
Your answer should be very brief. 6.74. What is the difference between the highest and the second highest Cost of communications, computer etc. (% of service exports) of Tunisia?
Give a very brief answer. 1.01. What is the difference between the highest and the lowest Cost of communications, computer etc. (% of service exports) of Marshall Islands?
Keep it short and to the point. 12.45. What is the difference between the highest and the lowest Cost of communications, computer etc. (% of service exports) in Timor-Leste?
Provide a short and direct response. 34.33. What is the difference between the highest and the lowest Cost of communications, computer etc. (% of service exports) of Tunisia?
Offer a terse response. 13.73. 